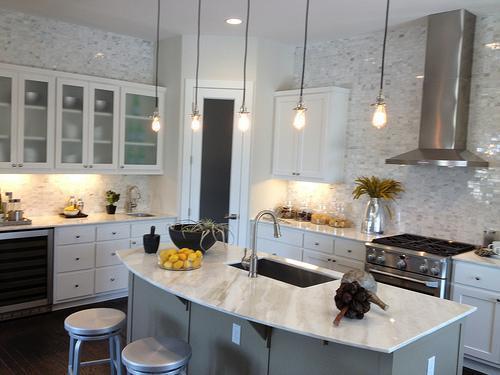How many faucets are nearby the bucket of lemon?
Give a very brief answer. 1. 